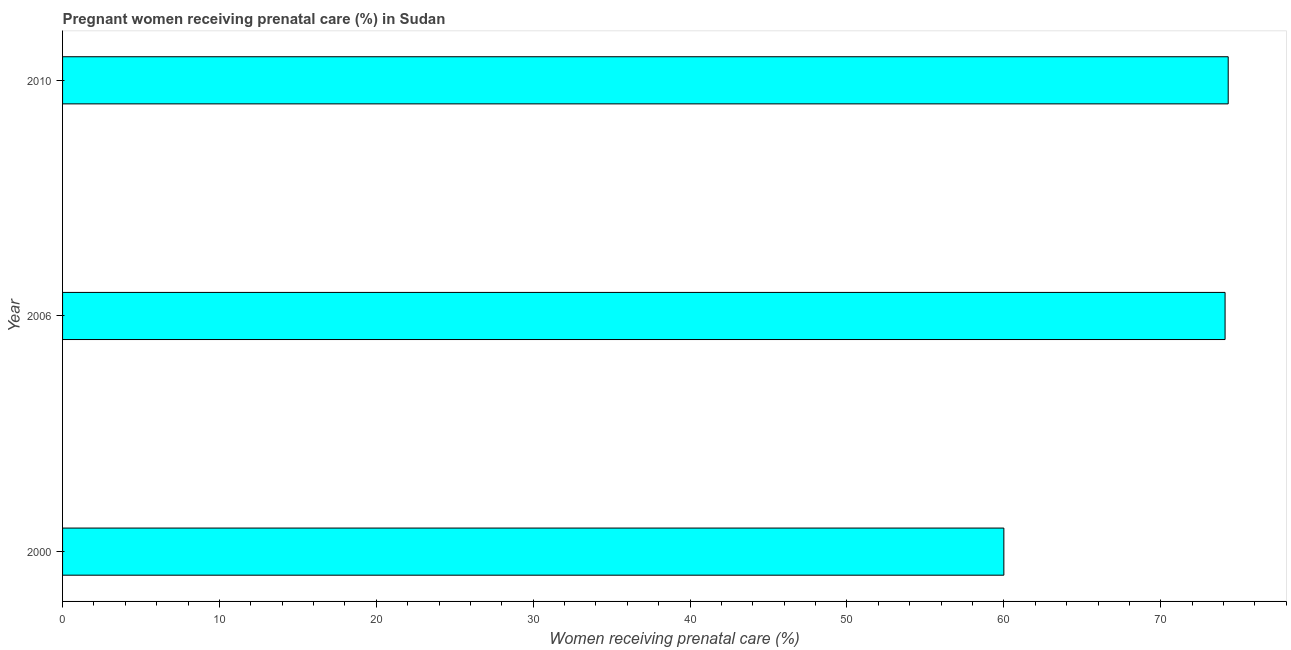What is the title of the graph?
Ensure brevity in your answer.  Pregnant women receiving prenatal care (%) in Sudan. What is the label or title of the X-axis?
Your response must be concise. Women receiving prenatal care (%). What is the label or title of the Y-axis?
Ensure brevity in your answer.  Year. What is the percentage of pregnant women receiving prenatal care in 2010?
Provide a short and direct response. 74.3. Across all years, what is the maximum percentage of pregnant women receiving prenatal care?
Offer a terse response. 74.3. In which year was the percentage of pregnant women receiving prenatal care maximum?
Offer a very short reply. 2010. What is the sum of the percentage of pregnant women receiving prenatal care?
Give a very brief answer. 208.4. What is the difference between the percentage of pregnant women receiving prenatal care in 2006 and 2010?
Your answer should be compact. -0.2. What is the average percentage of pregnant women receiving prenatal care per year?
Give a very brief answer. 69.47. What is the median percentage of pregnant women receiving prenatal care?
Your response must be concise. 74.1. Do a majority of the years between 2000 and 2010 (inclusive) have percentage of pregnant women receiving prenatal care greater than 44 %?
Provide a succinct answer. Yes. Is the percentage of pregnant women receiving prenatal care in 2000 less than that in 2006?
Make the answer very short. Yes. What is the difference between the highest and the second highest percentage of pregnant women receiving prenatal care?
Make the answer very short. 0.2. What is the difference between the highest and the lowest percentage of pregnant women receiving prenatal care?
Offer a very short reply. 14.3. What is the difference between two consecutive major ticks on the X-axis?
Offer a very short reply. 10. What is the Women receiving prenatal care (%) in 2000?
Make the answer very short. 60. What is the Women receiving prenatal care (%) in 2006?
Your response must be concise. 74.1. What is the Women receiving prenatal care (%) in 2010?
Provide a short and direct response. 74.3. What is the difference between the Women receiving prenatal care (%) in 2000 and 2006?
Ensure brevity in your answer.  -14.1. What is the difference between the Women receiving prenatal care (%) in 2000 and 2010?
Offer a terse response. -14.3. What is the ratio of the Women receiving prenatal care (%) in 2000 to that in 2006?
Offer a terse response. 0.81. What is the ratio of the Women receiving prenatal care (%) in 2000 to that in 2010?
Offer a very short reply. 0.81. What is the ratio of the Women receiving prenatal care (%) in 2006 to that in 2010?
Ensure brevity in your answer.  1. 